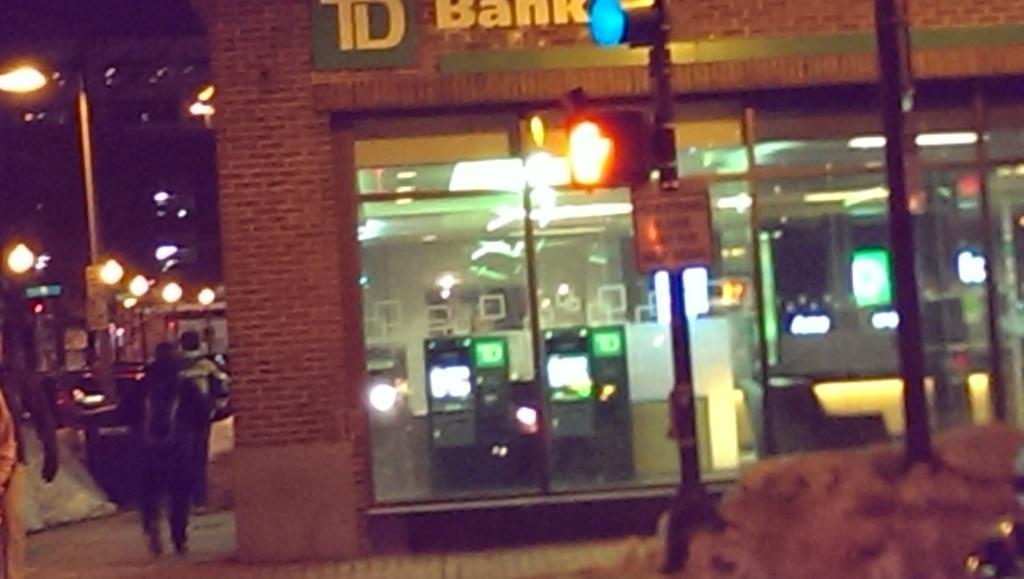How would you summarize this image in a sentence or two? In this image we can see a store, electric lights, mirrors, walls, information board, street poles, street lights and persons on the road. 